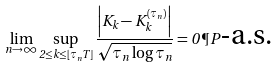<formula> <loc_0><loc_0><loc_500><loc_500>\lim _ { n \to \infty } \sup _ { 2 \leq k \leq \lfloor \tau _ { n } T \rfloor } \frac { \left | K _ { k } - K ^ { ( \tau _ { n } ) } _ { k } \right | } { \sqrt { \tau _ { n } \log \tau _ { n } } } = 0 \, \P P \text {-a.s.}</formula> 